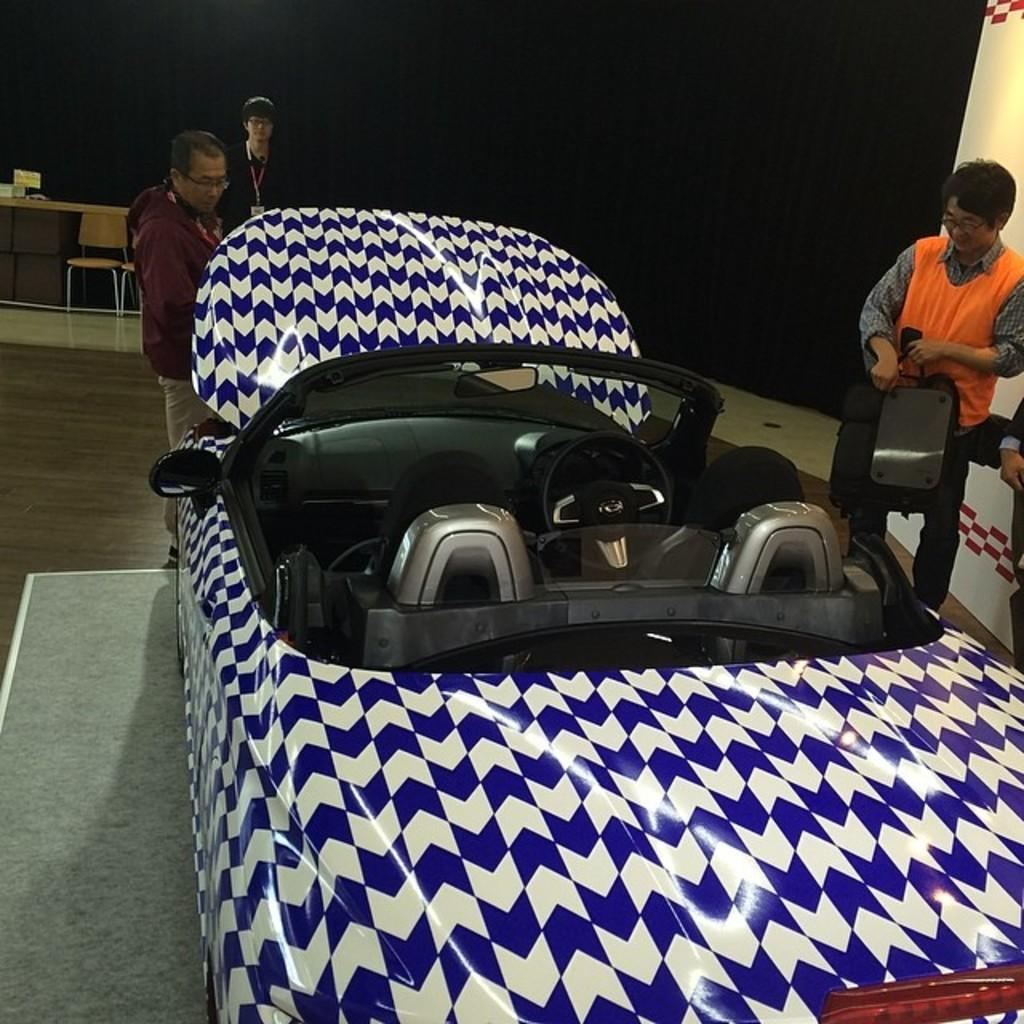What is the main object in the image? There is a vehicle in the image. What type of furniture can be seen in the image? There are chairs in the image. What is on the floor in the image? There is a floor mat in the image. Who or what is present in the image? There are people in the image. What type of cup is being used to set the rhythm in the image? There is no cup or rhythm present in the image. What type of kettle is visible in the image? There is no kettle present in the image. 